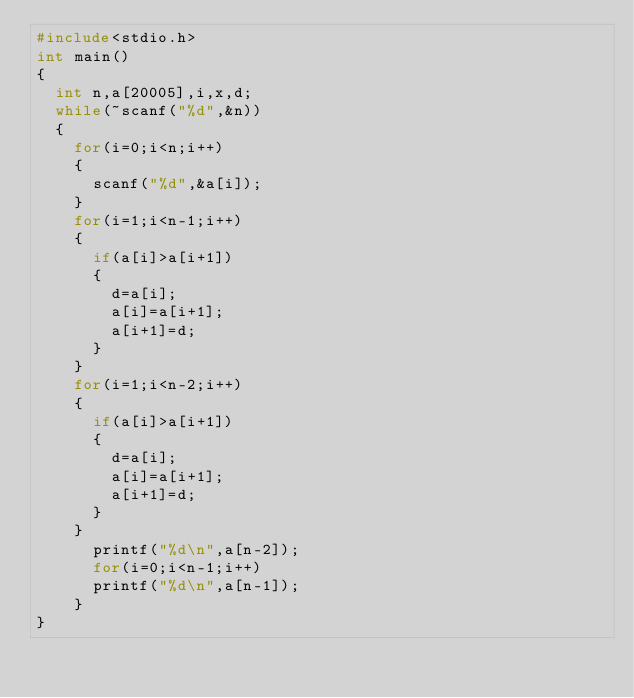<code> <loc_0><loc_0><loc_500><loc_500><_C++_>#include<stdio.h>
int main()
{
	int n,a[20005],i,x,d;
	while(~scanf("%d",&n))
	{
		for(i=0;i<n;i++)
		{
			scanf("%d",&a[i]);
		}
		for(i=1;i<n-1;i++)
		{
			if(a[i]>a[i+1])
			{
				d=a[i];
				a[i]=a[i+1];
				a[i+1]=d;
			}
		}
		for(i=1;i<n-2;i++)
		{
			if(a[i]>a[i+1])
			{
				d=a[i];
				a[i]=a[i+1];
				a[i+1]=d;
			}
		}
			printf("%d\n",a[n-2]);
			for(i=0;i<n-1;i++)
			printf("%d\n",a[n-1]);
		}
}</code> 